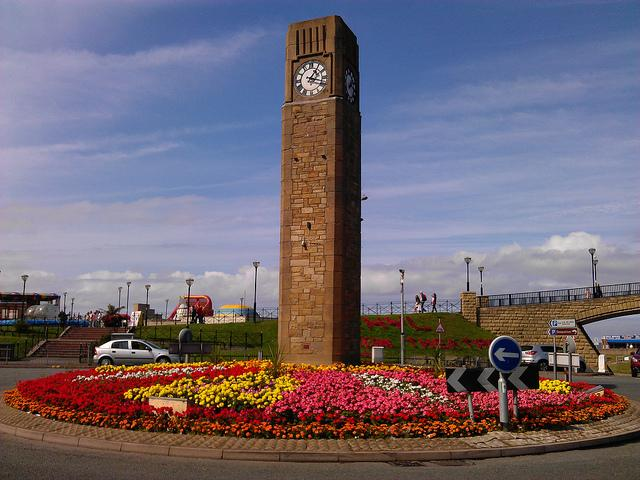What is the traffic pattern? Please explain your reasoning. intersection. The roundabout is a form of an intersection. 